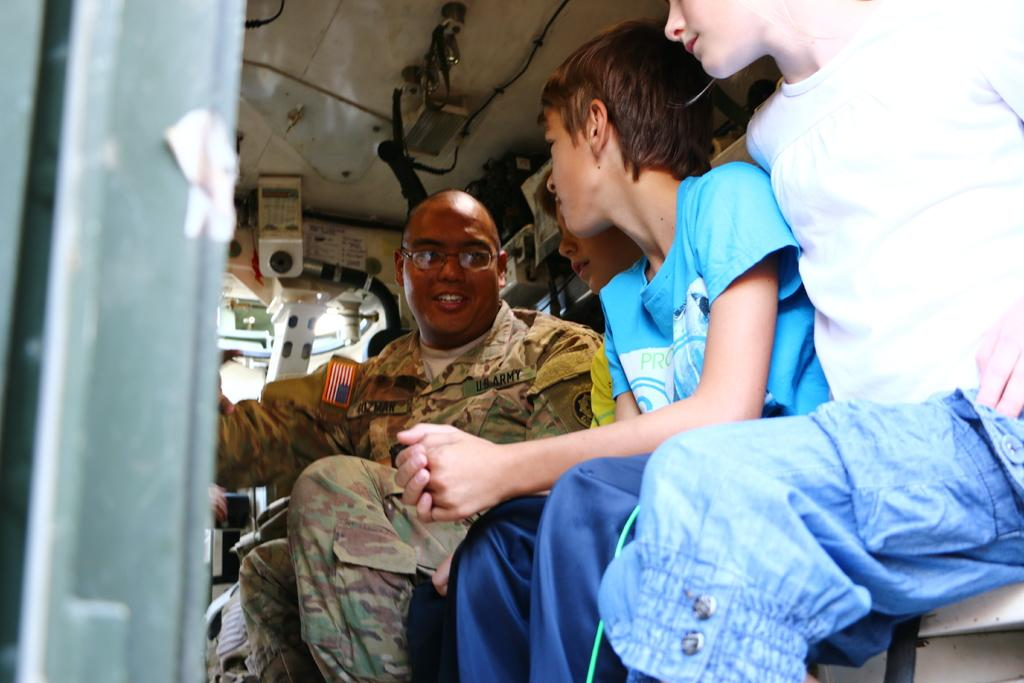How many people are in the vehicle in the image? There are four people in the vehicle in the image. What can be seen at the top of the image? There is a cable visible at the top of the image, as well as some objects. What type of arch can be seen in the image? There is no arch present in the image. What kind of toys are the people playing with in the vehicle? There is no indication of toys in the image; it only shows four people in a vehicle and a cable at the top. 